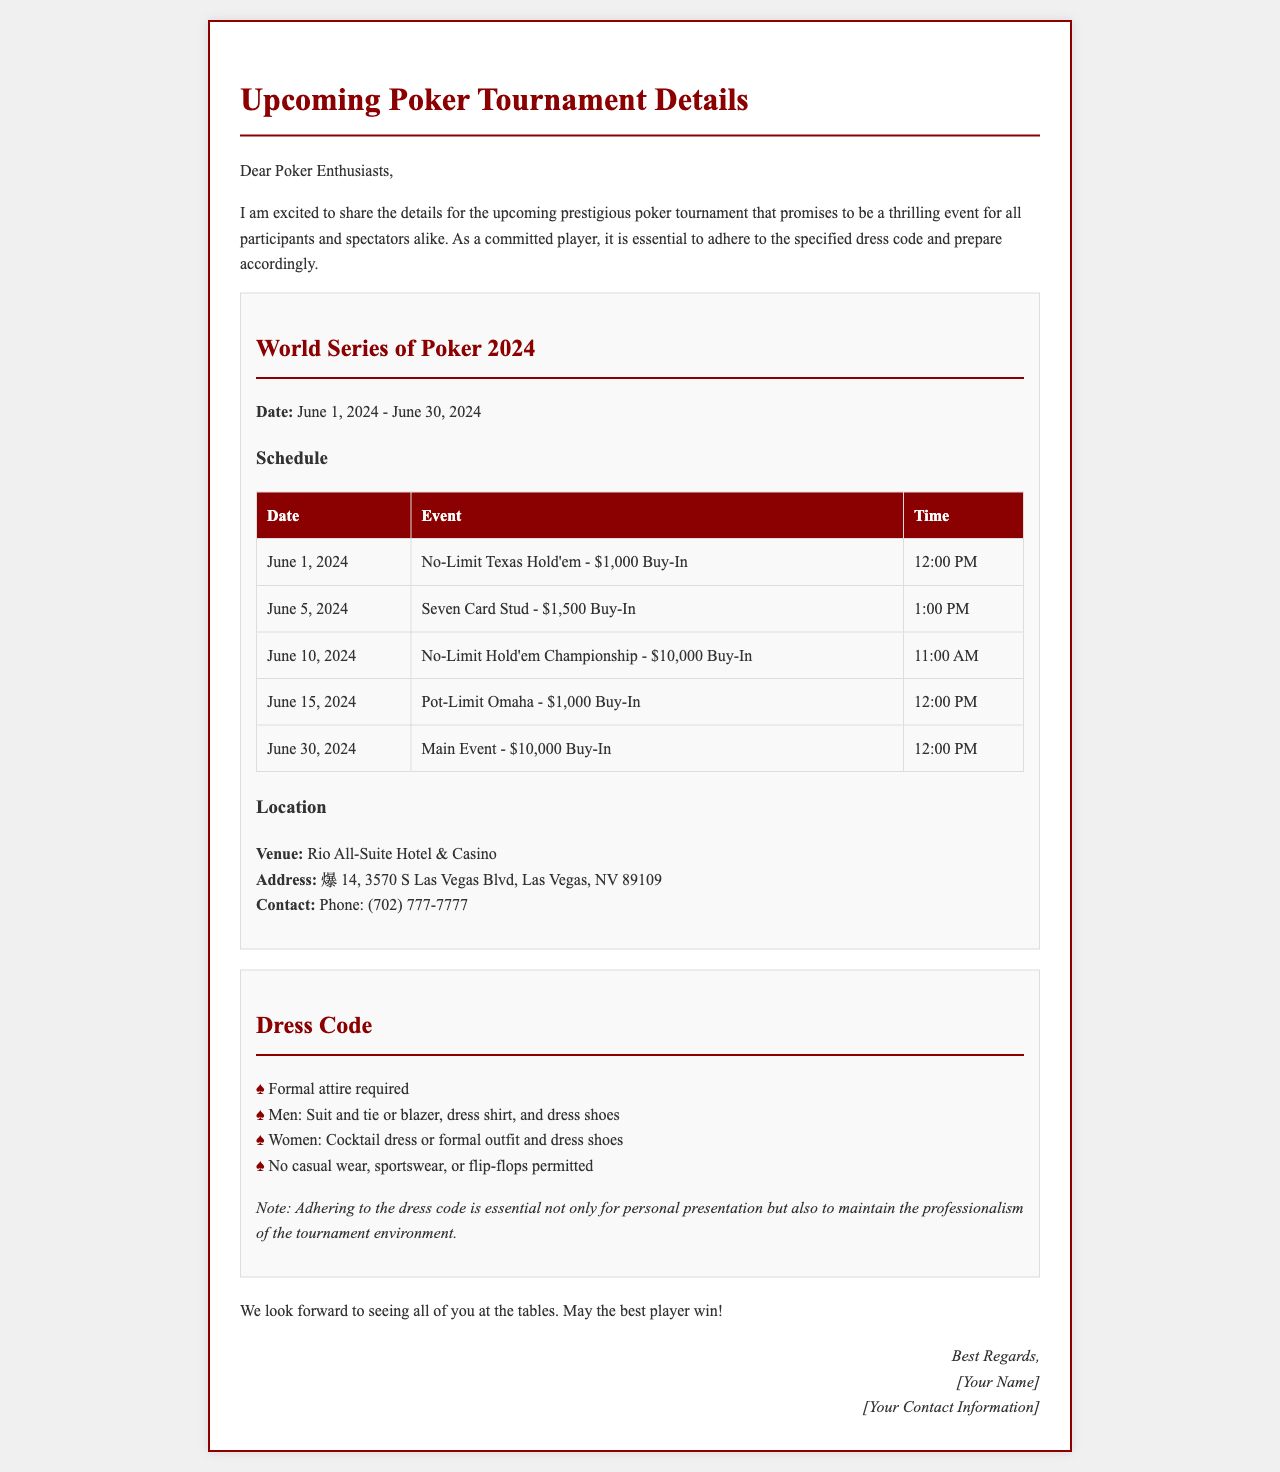What is the name of the tournament? The name of the tournament is explicitly stated in the document as the World Series of Poker 2024.
Answer: World Series of Poker 2024 What is the start date of the tournament? The start date of the tournament is provided in the document as June 1, 2024.
Answer: June 1, 2024 Where is the tournament being held? The venue for the tournament is mentioned in the document, specified as Rio All-Suite Hotel & Casino.
Answer: Rio All-Suite Hotel & Casino What is the dress code requirement for men? The dress code section explicitly states what is required for men, including "Suit and tie or blazer, dress shirt, and dress shoes."
Answer: Suit and tie or blazer, dress shirt, and dress shoes How many events are scheduled before the Main Event? The schedule lists the events leading up to the Main Event, specifically five events.
Answer: 5 What is the buy-in for the No-Limit Hold'em Championship? The document gives specific information about the buy-in for each event and states it as $10,000 for the No-Limit Hold'em Championship.
Answer: $10,000 What is prohibited in the dress code? The dress code section clearly mentions that "No casual wear, sportswear, or flip-flops permitted."
Answer: No casual wear, sportswear, or flip-flops What time does the Pot-Limit Omaha event start? The document lists the time for the Pot-Limit Omaha event as 12:00 PM in the schedule.
Answer: 12:00 PM What is the contact phone number for the venue? The contact information for the venue is provided, including the phone number (702) 777-7777.
Answer: (702) 777-7777 